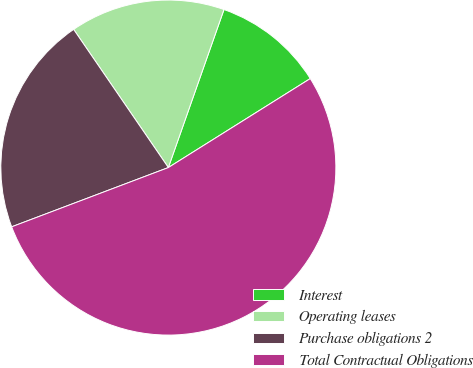Convert chart. <chart><loc_0><loc_0><loc_500><loc_500><pie_chart><fcel>Interest<fcel>Operating leases<fcel>Purchase obligations 2<fcel>Total Contractual Obligations<nl><fcel>10.7%<fcel>14.95%<fcel>21.19%<fcel>53.16%<nl></chart> 